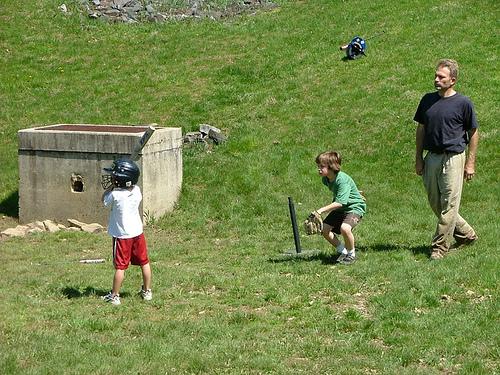Is the man worried about the children?
Concise answer only. No. Are shadows cast?
Be succinct. Yes. How many children are in the photo?
Write a very short answer. 2. 